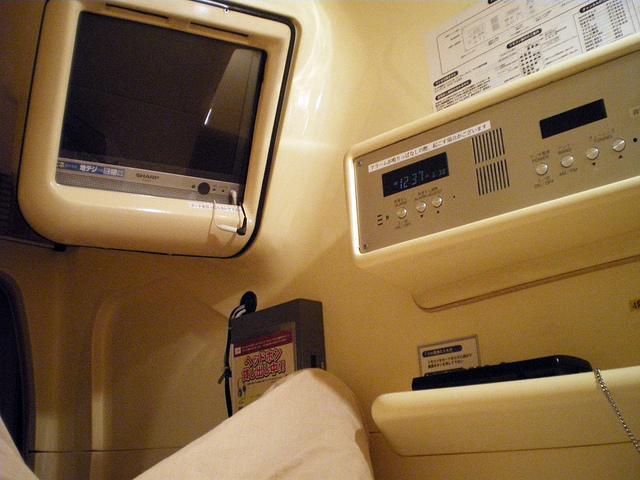What room was this taken in?
Concise answer only. Hospital room. What is the monitor used for?
Give a very brief answer. Medical. What numbers are on the clock?
Concise answer only. 1237. 